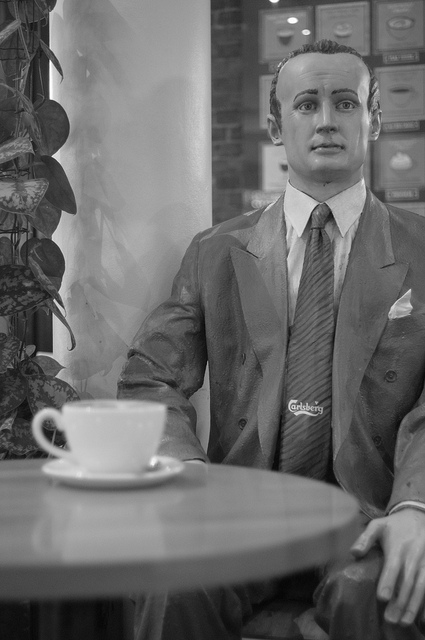Identify the text contained in this image. Carlsberg 